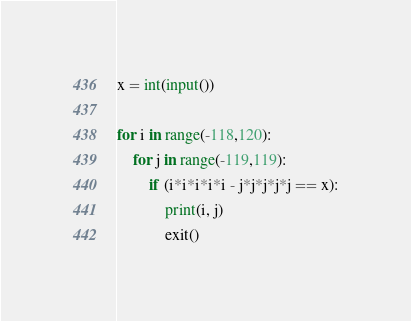Convert code to text. <code><loc_0><loc_0><loc_500><loc_500><_Python_>x = int(input())

for i in range(-118,120):
    for j in range(-119,119):
        if (i*i*i*i*i - j*j*j*j*j == x):
            print(i, j)
            exit()</code> 